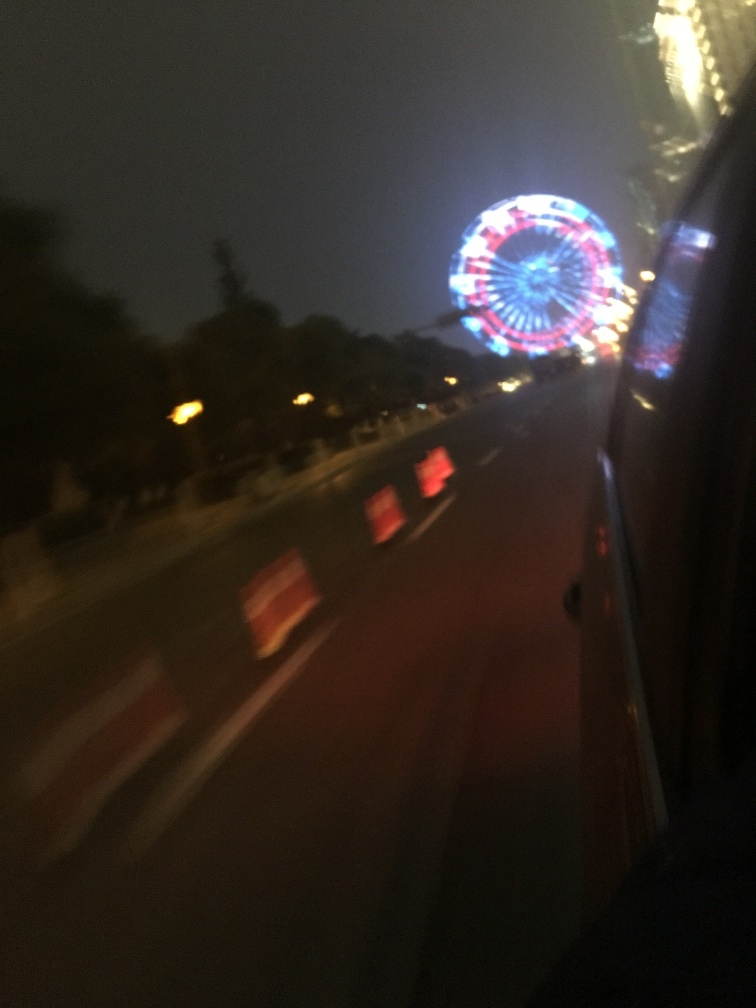What time of day does this image depict, and what does that suggest about the location? The image was taken during nighttime, evident from the dark sky and artificial lighting, specifically from the Ferris wheel. Nighttime settings with lit attractions like this often suggest a lively urban area with active nightlife or a special event occurring. 